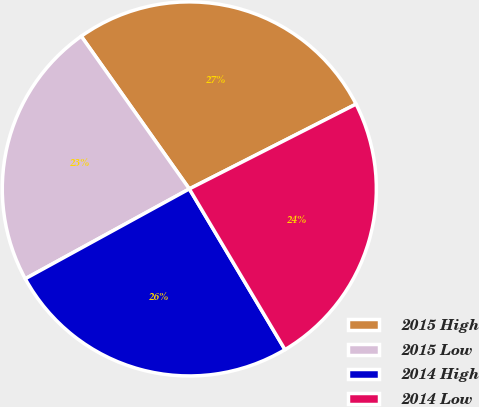<chart> <loc_0><loc_0><loc_500><loc_500><pie_chart><fcel>2015 High<fcel>2015 Low<fcel>2014 High<fcel>2014 Low<nl><fcel>27.31%<fcel>23.17%<fcel>25.57%<fcel>23.94%<nl></chart> 